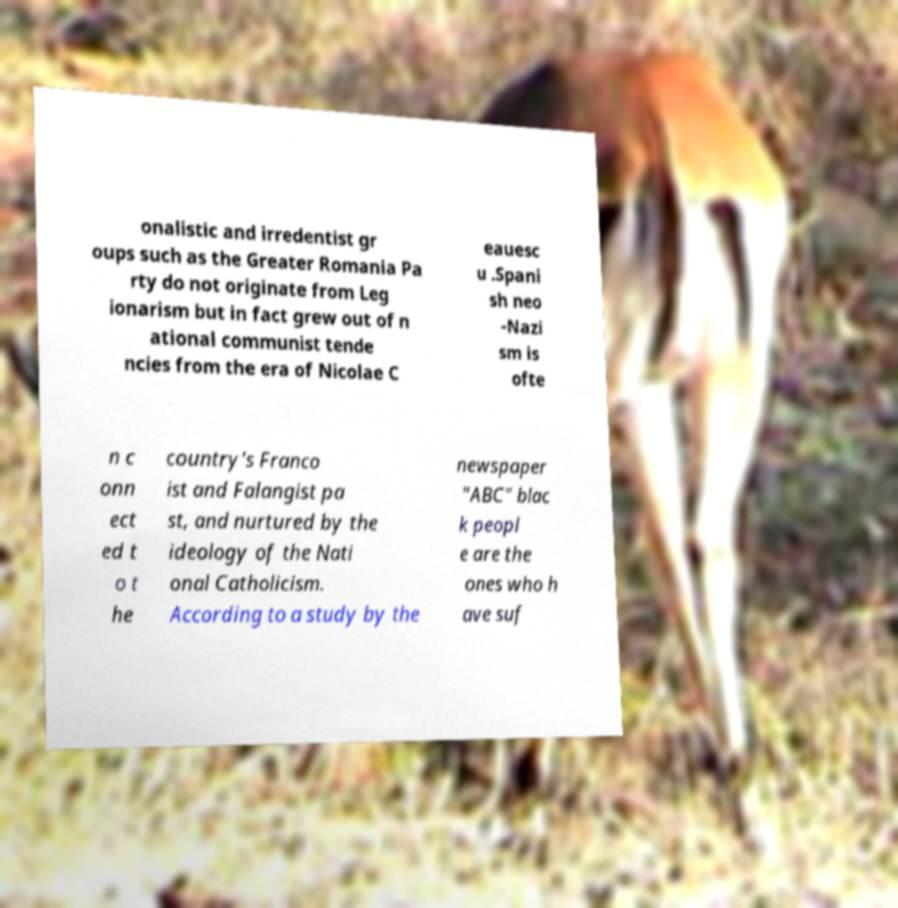I need the written content from this picture converted into text. Can you do that? onalistic and irredentist gr oups such as the Greater Romania Pa rty do not originate from Leg ionarism but in fact grew out of n ational communist tende ncies from the era of Nicolae C eauesc u .Spani sh neo -Nazi sm is ofte n c onn ect ed t o t he country's Franco ist and Falangist pa st, and nurtured by the ideology of the Nati onal Catholicism. According to a study by the newspaper "ABC" blac k peopl e are the ones who h ave suf 